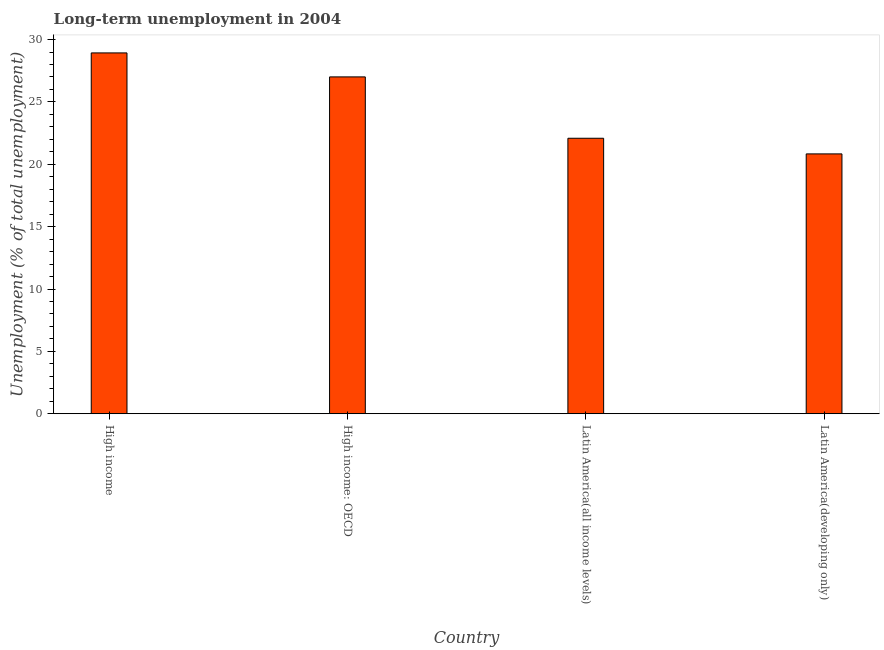Does the graph contain any zero values?
Provide a short and direct response. No. What is the title of the graph?
Provide a short and direct response. Long-term unemployment in 2004. What is the label or title of the Y-axis?
Provide a short and direct response. Unemployment (% of total unemployment). What is the long-term unemployment in Latin America(all income levels)?
Your response must be concise. 22.09. Across all countries, what is the maximum long-term unemployment?
Your answer should be very brief. 28.93. Across all countries, what is the minimum long-term unemployment?
Provide a short and direct response. 20.83. In which country was the long-term unemployment maximum?
Your answer should be compact. High income. In which country was the long-term unemployment minimum?
Your answer should be very brief. Latin America(developing only). What is the sum of the long-term unemployment?
Provide a succinct answer. 98.85. What is the difference between the long-term unemployment in Latin America(all income levels) and Latin America(developing only)?
Provide a succinct answer. 1.25. What is the average long-term unemployment per country?
Your response must be concise. 24.71. What is the median long-term unemployment?
Ensure brevity in your answer.  24.55. In how many countries, is the long-term unemployment greater than 1 %?
Your response must be concise. 4. What is the ratio of the long-term unemployment in High income: OECD to that in Latin America(developing only)?
Provide a succinct answer. 1.3. Is the difference between the long-term unemployment in High income: OECD and Latin America(all income levels) greater than the difference between any two countries?
Provide a short and direct response. No. What is the difference between the highest and the second highest long-term unemployment?
Make the answer very short. 1.92. What is the difference between the highest and the lowest long-term unemployment?
Make the answer very short. 8.1. In how many countries, is the long-term unemployment greater than the average long-term unemployment taken over all countries?
Make the answer very short. 2. How many bars are there?
Ensure brevity in your answer.  4. How many countries are there in the graph?
Your answer should be very brief. 4. Are the values on the major ticks of Y-axis written in scientific E-notation?
Your answer should be compact. No. What is the Unemployment (% of total unemployment) of High income?
Give a very brief answer. 28.93. What is the Unemployment (% of total unemployment) in High income: OECD?
Offer a terse response. 27.01. What is the Unemployment (% of total unemployment) of Latin America(all income levels)?
Your answer should be compact. 22.09. What is the Unemployment (% of total unemployment) in Latin America(developing only)?
Your response must be concise. 20.83. What is the difference between the Unemployment (% of total unemployment) in High income and High income: OECD?
Give a very brief answer. 1.92. What is the difference between the Unemployment (% of total unemployment) in High income and Latin America(all income levels)?
Your response must be concise. 6.84. What is the difference between the Unemployment (% of total unemployment) in High income and Latin America(developing only)?
Ensure brevity in your answer.  8.1. What is the difference between the Unemployment (% of total unemployment) in High income: OECD and Latin America(all income levels)?
Offer a very short reply. 4.92. What is the difference between the Unemployment (% of total unemployment) in High income: OECD and Latin America(developing only)?
Your answer should be compact. 6.17. What is the difference between the Unemployment (% of total unemployment) in Latin America(all income levels) and Latin America(developing only)?
Make the answer very short. 1.25. What is the ratio of the Unemployment (% of total unemployment) in High income to that in High income: OECD?
Provide a succinct answer. 1.07. What is the ratio of the Unemployment (% of total unemployment) in High income to that in Latin America(all income levels)?
Offer a terse response. 1.31. What is the ratio of the Unemployment (% of total unemployment) in High income to that in Latin America(developing only)?
Provide a succinct answer. 1.39. What is the ratio of the Unemployment (% of total unemployment) in High income: OECD to that in Latin America(all income levels)?
Ensure brevity in your answer.  1.22. What is the ratio of the Unemployment (% of total unemployment) in High income: OECD to that in Latin America(developing only)?
Provide a succinct answer. 1.3. What is the ratio of the Unemployment (% of total unemployment) in Latin America(all income levels) to that in Latin America(developing only)?
Your answer should be very brief. 1.06. 